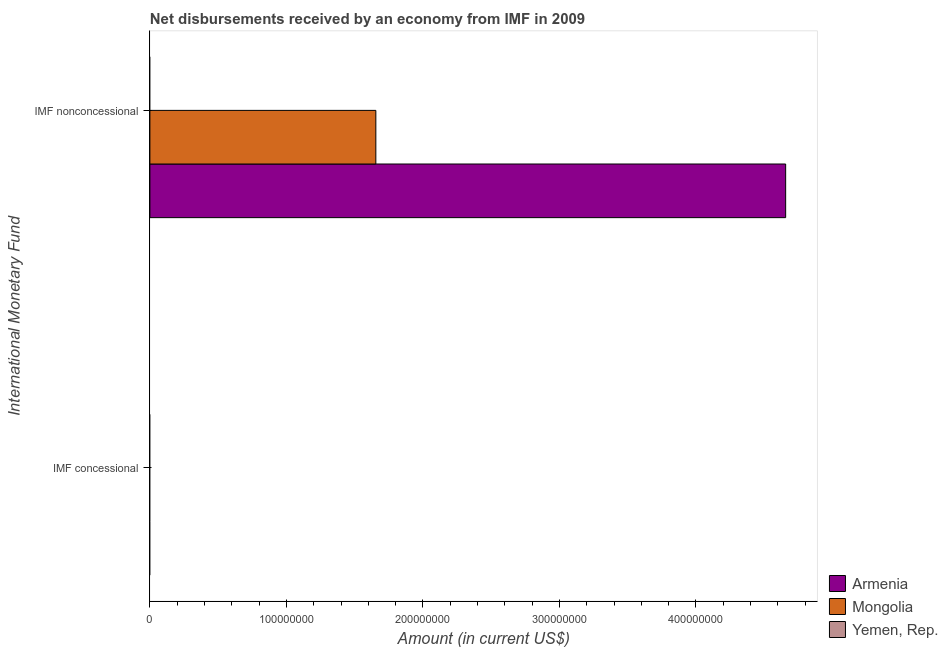Are the number of bars per tick equal to the number of legend labels?
Your answer should be compact. No. Are the number of bars on each tick of the Y-axis equal?
Provide a succinct answer. No. How many bars are there on the 2nd tick from the bottom?
Offer a terse response. 2. What is the label of the 2nd group of bars from the top?
Make the answer very short. IMF concessional. Across all countries, what is the maximum net non concessional disbursements from imf?
Your answer should be compact. 4.66e+08. Across all countries, what is the minimum net non concessional disbursements from imf?
Your response must be concise. 0. In which country was the net non concessional disbursements from imf maximum?
Your answer should be very brief. Armenia. What is the total net non concessional disbursements from imf in the graph?
Keep it short and to the point. 6.31e+08. What is the difference between the net non concessional disbursements from imf in Mongolia and the net concessional disbursements from imf in Yemen, Rep.?
Your answer should be very brief. 1.66e+08. What is the average net concessional disbursements from imf per country?
Offer a very short reply. 0. Are the values on the major ticks of X-axis written in scientific E-notation?
Offer a very short reply. No. Does the graph contain any zero values?
Your response must be concise. Yes. Does the graph contain grids?
Ensure brevity in your answer.  No. How many legend labels are there?
Provide a short and direct response. 3. How are the legend labels stacked?
Provide a short and direct response. Vertical. What is the title of the graph?
Your answer should be very brief. Net disbursements received by an economy from IMF in 2009. What is the label or title of the X-axis?
Your answer should be compact. Amount (in current US$). What is the label or title of the Y-axis?
Your answer should be very brief. International Monetary Fund. What is the Amount (in current US$) in Armenia in IMF nonconcessional?
Offer a very short reply. 4.66e+08. What is the Amount (in current US$) of Mongolia in IMF nonconcessional?
Your response must be concise. 1.66e+08. What is the Amount (in current US$) in Yemen, Rep. in IMF nonconcessional?
Offer a very short reply. 0. Across all International Monetary Fund, what is the maximum Amount (in current US$) of Armenia?
Your answer should be very brief. 4.66e+08. Across all International Monetary Fund, what is the maximum Amount (in current US$) in Mongolia?
Offer a very short reply. 1.66e+08. Across all International Monetary Fund, what is the minimum Amount (in current US$) in Armenia?
Your response must be concise. 0. What is the total Amount (in current US$) in Armenia in the graph?
Provide a succinct answer. 4.66e+08. What is the total Amount (in current US$) in Mongolia in the graph?
Provide a short and direct response. 1.66e+08. What is the average Amount (in current US$) in Armenia per International Monetary Fund?
Ensure brevity in your answer.  2.33e+08. What is the average Amount (in current US$) in Mongolia per International Monetary Fund?
Provide a succinct answer. 8.28e+07. What is the difference between the Amount (in current US$) in Armenia and Amount (in current US$) in Mongolia in IMF nonconcessional?
Your response must be concise. 3.00e+08. What is the difference between the highest and the lowest Amount (in current US$) of Armenia?
Keep it short and to the point. 4.66e+08. What is the difference between the highest and the lowest Amount (in current US$) of Mongolia?
Ensure brevity in your answer.  1.66e+08. 